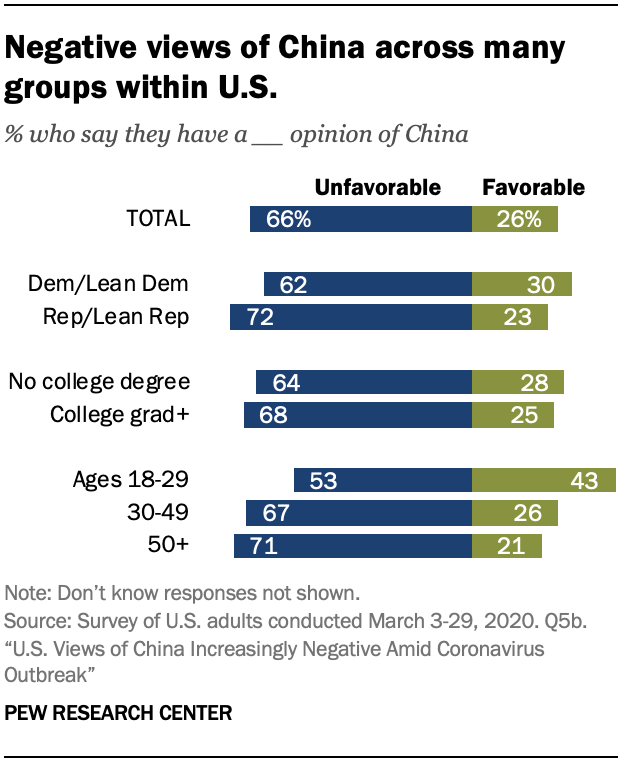Identify some key points in this picture. The sum of the values of blue bars that exceed 70 is 143. The color of the bar that represents the percentage value of 26 in the "TOTAL" category is green. 